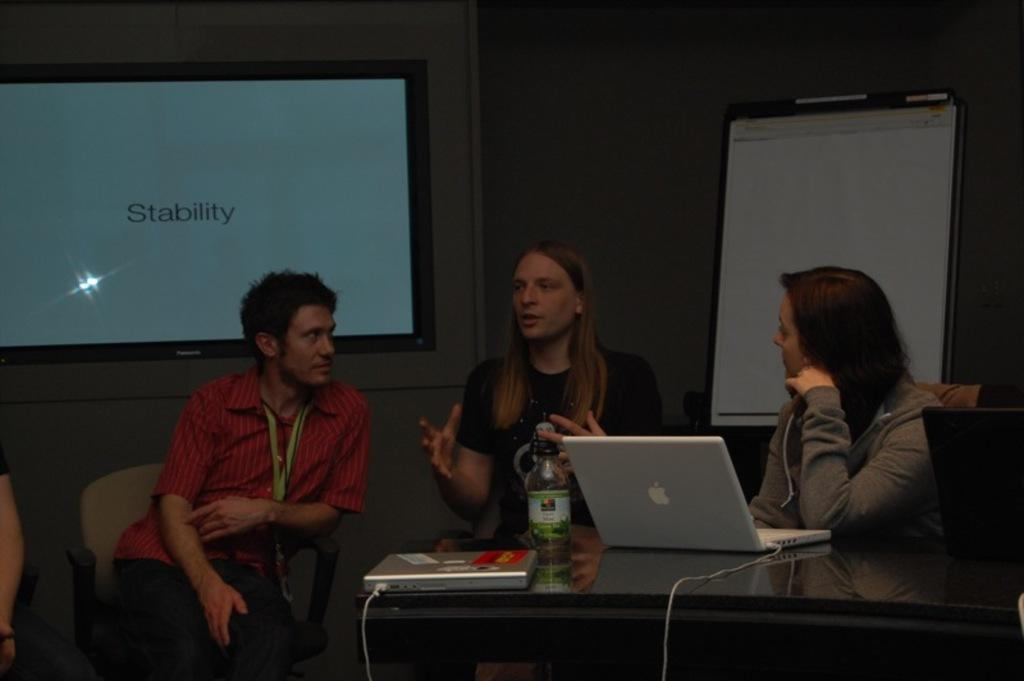How many people are in the image? There are three people in the image. What are the people doing in the image? The people are sitting on a chair. Where are the people located in relation to the table? The people are in front of a table. What electronic device is on the table? There is a laptop on the table. What other objects can be seen on the table? There are other objects on the table. What type of growth can be observed on the owl in the image? There is no owl present in the image, so no growth can be observed. 